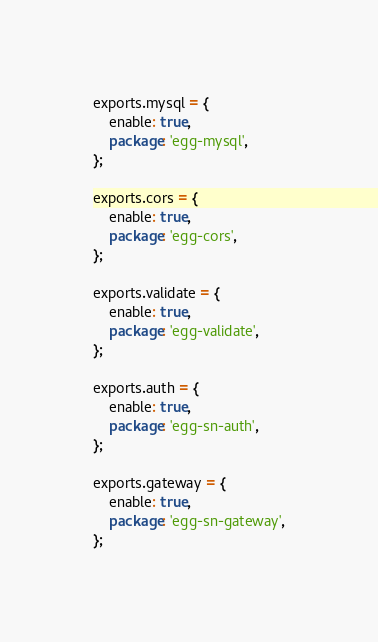Convert code to text. <code><loc_0><loc_0><loc_500><loc_500><_JavaScript_>exports.mysql = {
    enable: true,
    package: 'egg-mysql',
};

exports.cors = {
    enable: true,
    package: 'egg-cors',
};

exports.validate = {
    enable: true,
    package: 'egg-validate',
};

exports.auth = {
    enable: true,
    package: 'egg-sn-auth',
};

exports.gateway = {
    enable: true,
    package: 'egg-sn-gateway',
};</code> 